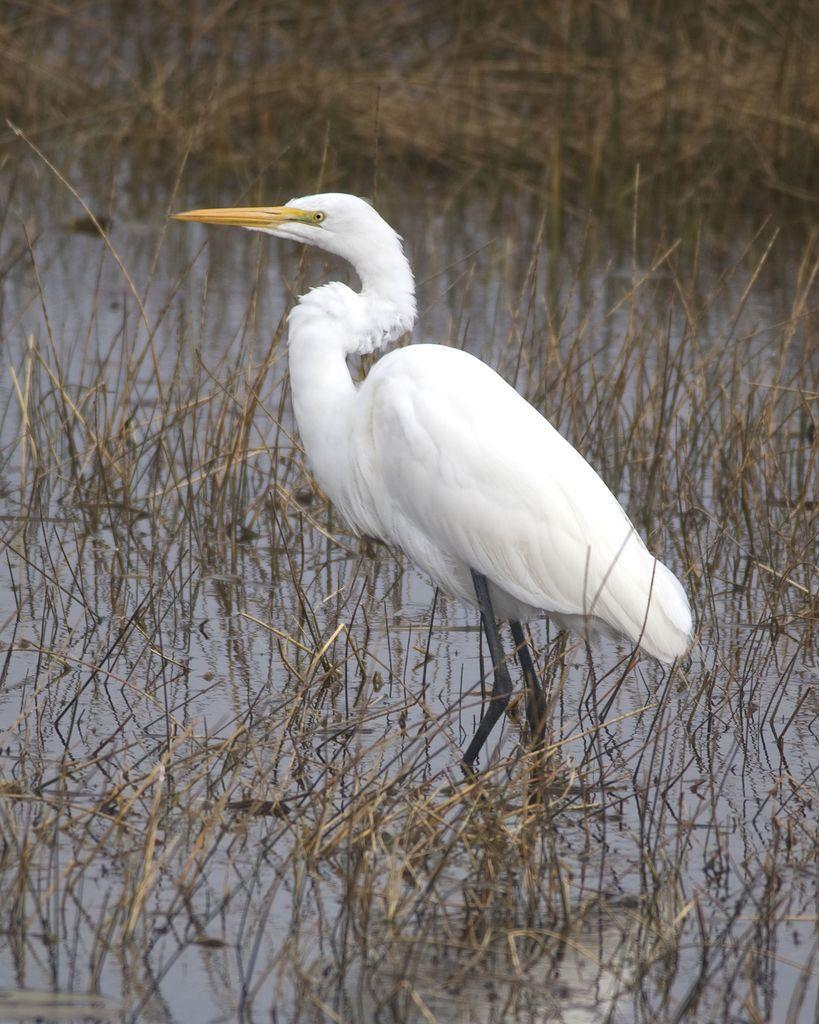Describe this image in one or two sentences. In this picture we can see a bird and a few twigs in the water. 